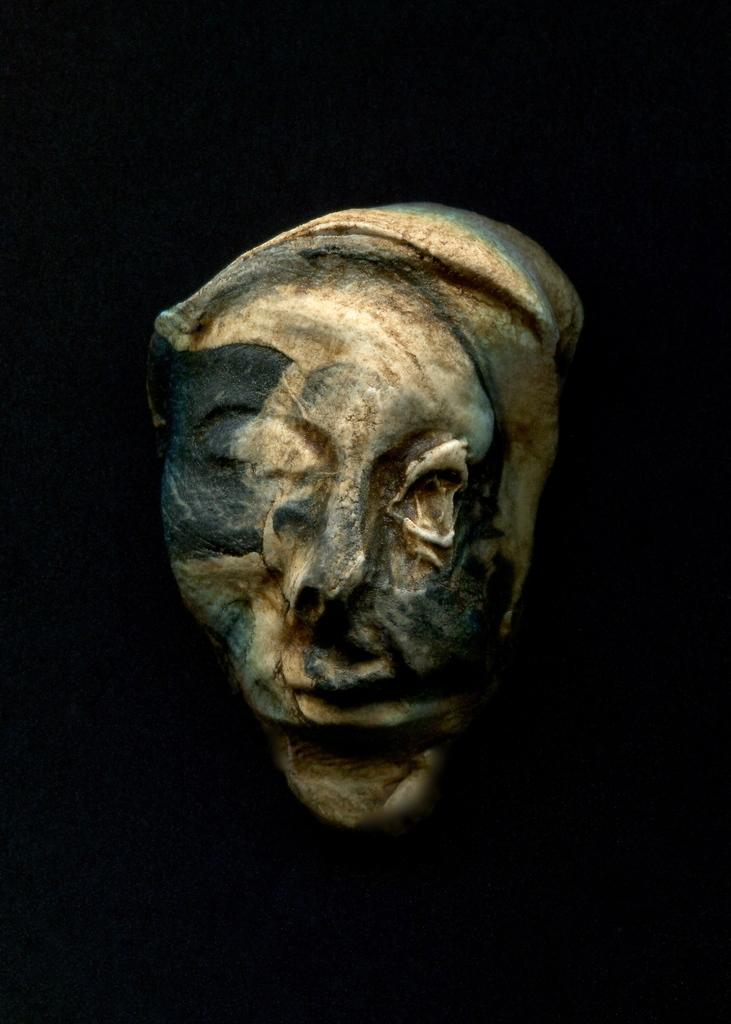What is the main subject of the image? There is a sculpture in the image. What color is the background of the image? The background of the image is black. What type of vest is the sculpture wearing in the image? There is no vest present in the image, as it features a sculpture with no clothing. 